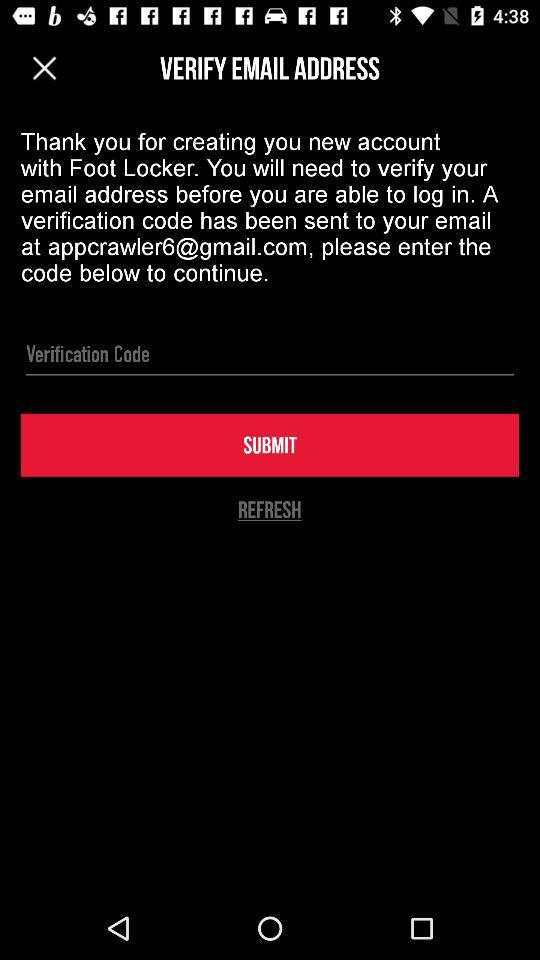What's the name of the Google mail address used by the user for application? The email address is appcrawler6@gmail.com. 